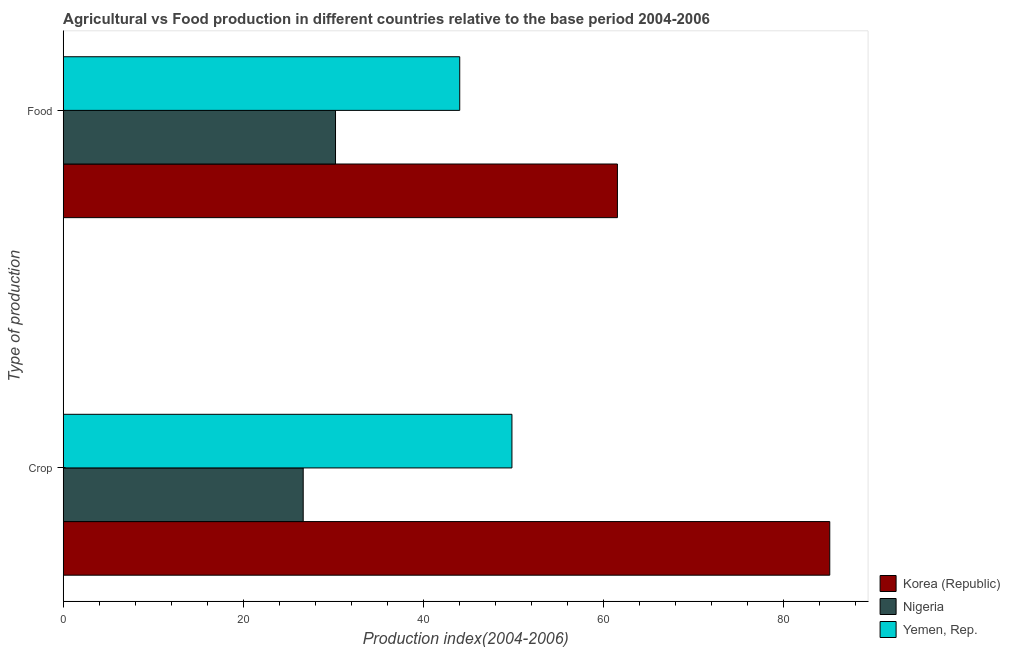How many different coloured bars are there?
Make the answer very short. 3. How many groups of bars are there?
Make the answer very short. 2. What is the label of the 1st group of bars from the top?
Your answer should be very brief. Food. What is the food production index in Nigeria?
Keep it short and to the point. 30.25. Across all countries, what is the maximum crop production index?
Ensure brevity in your answer.  85.16. Across all countries, what is the minimum food production index?
Provide a short and direct response. 30.25. In which country was the crop production index minimum?
Provide a succinct answer. Nigeria. What is the total crop production index in the graph?
Provide a short and direct response. 161.67. What is the difference between the food production index in Korea (Republic) and that in Yemen, Rep.?
Offer a very short reply. 17.52. What is the difference between the food production index in Yemen, Rep. and the crop production index in Korea (Republic)?
Give a very brief answer. -41.11. What is the average food production index per country?
Provide a short and direct response. 45.29. What is the difference between the food production index and crop production index in Korea (Republic)?
Offer a very short reply. -23.59. In how many countries, is the food production index greater than 4 ?
Give a very brief answer. 3. What is the ratio of the crop production index in Korea (Republic) to that in Nigeria?
Offer a very short reply. 3.19. Is the food production index in Yemen, Rep. less than that in Nigeria?
Make the answer very short. No. What does the 1st bar from the top in Crop represents?
Provide a short and direct response. Yemen, Rep. What does the 3rd bar from the bottom in Crop represents?
Offer a terse response. Yemen, Rep. How many bars are there?
Ensure brevity in your answer.  6. How many countries are there in the graph?
Offer a terse response. 3. What is the difference between two consecutive major ticks on the X-axis?
Keep it short and to the point. 20. Does the graph contain any zero values?
Provide a succinct answer. No. How many legend labels are there?
Keep it short and to the point. 3. What is the title of the graph?
Give a very brief answer. Agricultural vs Food production in different countries relative to the base period 2004-2006. What is the label or title of the X-axis?
Your response must be concise. Production index(2004-2006). What is the label or title of the Y-axis?
Provide a short and direct response. Type of production. What is the Production index(2004-2006) of Korea (Republic) in Crop?
Your answer should be very brief. 85.16. What is the Production index(2004-2006) of Nigeria in Crop?
Offer a very short reply. 26.66. What is the Production index(2004-2006) in Yemen, Rep. in Crop?
Your answer should be compact. 49.85. What is the Production index(2004-2006) in Korea (Republic) in Food?
Offer a very short reply. 61.57. What is the Production index(2004-2006) of Nigeria in Food?
Your response must be concise. 30.25. What is the Production index(2004-2006) of Yemen, Rep. in Food?
Give a very brief answer. 44.05. Across all Type of production, what is the maximum Production index(2004-2006) of Korea (Republic)?
Offer a very short reply. 85.16. Across all Type of production, what is the maximum Production index(2004-2006) in Nigeria?
Ensure brevity in your answer.  30.25. Across all Type of production, what is the maximum Production index(2004-2006) in Yemen, Rep.?
Your answer should be compact. 49.85. Across all Type of production, what is the minimum Production index(2004-2006) of Korea (Republic)?
Offer a very short reply. 61.57. Across all Type of production, what is the minimum Production index(2004-2006) in Nigeria?
Your answer should be compact. 26.66. Across all Type of production, what is the minimum Production index(2004-2006) of Yemen, Rep.?
Keep it short and to the point. 44.05. What is the total Production index(2004-2006) in Korea (Republic) in the graph?
Your answer should be compact. 146.73. What is the total Production index(2004-2006) of Nigeria in the graph?
Your answer should be very brief. 56.91. What is the total Production index(2004-2006) in Yemen, Rep. in the graph?
Offer a very short reply. 93.9. What is the difference between the Production index(2004-2006) in Korea (Republic) in Crop and that in Food?
Provide a succinct answer. 23.59. What is the difference between the Production index(2004-2006) of Nigeria in Crop and that in Food?
Make the answer very short. -3.59. What is the difference between the Production index(2004-2006) in Korea (Republic) in Crop and the Production index(2004-2006) in Nigeria in Food?
Your response must be concise. 54.91. What is the difference between the Production index(2004-2006) of Korea (Republic) in Crop and the Production index(2004-2006) of Yemen, Rep. in Food?
Ensure brevity in your answer.  41.11. What is the difference between the Production index(2004-2006) of Nigeria in Crop and the Production index(2004-2006) of Yemen, Rep. in Food?
Offer a terse response. -17.39. What is the average Production index(2004-2006) in Korea (Republic) per Type of production?
Ensure brevity in your answer.  73.36. What is the average Production index(2004-2006) of Nigeria per Type of production?
Your response must be concise. 28.45. What is the average Production index(2004-2006) in Yemen, Rep. per Type of production?
Ensure brevity in your answer.  46.95. What is the difference between the Production index(2004-2006) of Korea (Republic) and Production index(2004-2006) of Nigeria in Crop?
Your response must be concise. 58.5. What is the difference between the Production index(2004-2006) in Korea (Republic) and Production index(2004-2006) in Yemen, Rep. in Crop?
Make the answer very short. 35.31. What is the difference between the Production index(2004-2006) of Nigeria and Production index(2004-2006) of Yemen, Rep. in Crop?
Ensure brevity in your answer.  -23.19. What is the difference between the Production index(2004-2006) of Korea (Republic) and Production index(2004-2006) of Nigeria in Food?
Offer a terse response. 31.32. What is the difference between the Production index(2004-2006) of Korea (Republic) and Production index(2004-2006) of Yemen, Rep. in Food?
Your answer should be very brief. 17.52. What is the difference between the Production index(2004-2006) in Nigeria and Production index(2004-2006) in Yemen, Rep. in Food?
Your response must be concise. -13.8. What is the ratio of the Production index(2004-2006) of Korea (Republic) in Crop to that in Food?
Your response must be concise. 1.38. What is the ratio of the Production index(2004-2006) of Nigeria in Crop to that in Food?
Give a very brief answer. 0.88. What is the ratio of the Production index(2004-2006) of Yemen, Rep. in Crop to that in Food?
Provide a succinct answer. 1.13. What is the difference between the highest and the second highest Production index(2004-2006) of Korea (Republic)?
Offer a very short reply. 23.59. What is the difference between the highest and the second highest Production index(2004-2006) of Nigeria?
Offer a very short reply. 3.59. What is the difference between the highest and the second highest Production index(2004-2006) of Yemen, Rep.?
Provide a short and direct response. 5.8. What is the difference between the highest and the lowest Production index(2004-2006) of Korea (Republic)?
Give a very brief answer. 23.59. What is the difference between the highest and the lowest Production index(2004-2006) in Nigeria?
Give a very brief answer. 3.59. What is the difference between the highest and the lowest Production index(2004-2006) in Yemen, Rep.?
Provide a short and direct response. 5.8. 